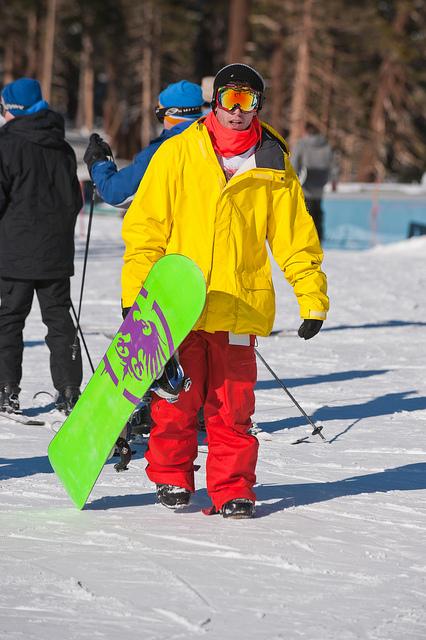What color are the persons pants?
Give a very brief answer. Red. Is the man ascending or descending?
Quick response, please. Ascending. What activity is the child doing?
Write a very short answer. Snowboarding. What color is the kid's helmet?
Short answer required. Black. What is the skier holding in his hands?
Write a very short answer. Snowboard. What color is the snowboard?
Keep it brief. Green. What activity is this man engaging in?
Answer briefly. Snowboarding. What are the people doing?
Answer briefly. Snowboarding. What is the man in the yellow jacket holding?
Give a very brief answer. Snowboard. What is the color of the man's jacket?
Concise answer only. Yellow. Are these adults?
Answer briefly. Yes. Are the people the same height?
Quick response, please. Yes. What's on his face?
Quick response, please. Goggles. What is the man standing on?
Write a very short answer. Snow. Why does the man have goggles on?
Write a very short answer. Snowboarding. What do the people have in their hands?
Give a very brief answer. Snowboard. What is on the snow?
Write a very short answer. People. Why is the man on the snow?
Quick response, please. Snowboarding. What sport are they about to do?
Give a very brief answer. Snowboarding. What is the orange hat made of?
Keep it brief. Knit. Is the person skiing?
Write a very short answer. No. How many poles are there?
Concise answer only. 2. What is this guy doing?
Quick response, please. Snowboarding. Is this person snowboarding?
Short answer required. Yes. 